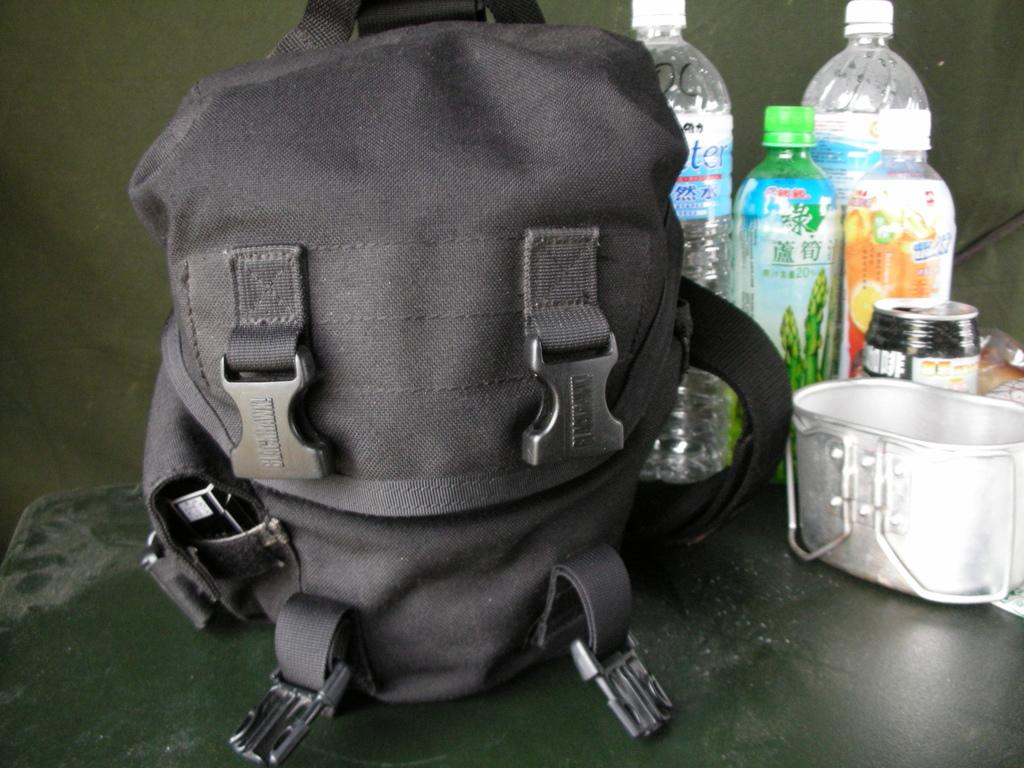What object can be seen in the image that might be used for carrying items? There is a bag in the image that might be used for carrying items. What type of containers are visible in the image? There are bottles and a can in the image. What object in the image might be used for eating or cooking? There is a utensil in the image that might be used for eating or cooking. Where is the hat located in the image? There is no hat present in the image. What type of stage is visible in the image? There is no stage present in the image. 